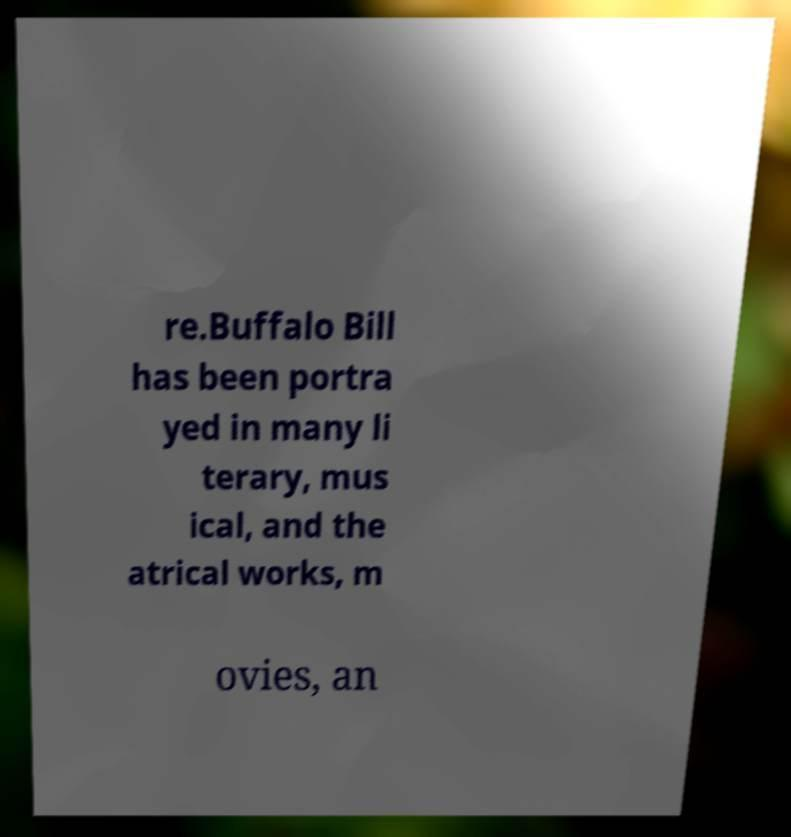Please identify and transcribe the text found in this image. re.Buffalo Bill has been portra yed in many li terary, mus ical, and the atrical works, m ovies, an 